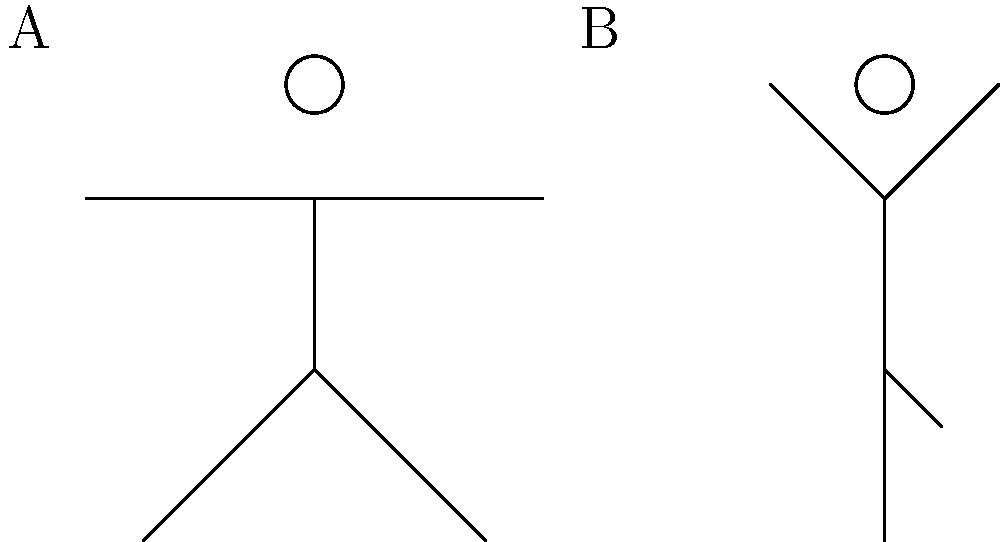As a nurse who understands the importance of stress relief, you recommend yoga to your patients. Which of the stick figure diagrams (A or B) represents the Warrior II pose, a stance known for building strength and reducing anxiety? To identify the Warrior II pose, let's analyze both stick figures:

1. Figure A:
   - Arms are extended horizontally
   - Legs are in a wide stance
   - One leg appears bent (front leg in Warrior II)
   - Upper body is upright

2. Figure B:
   - Arms are raised above the head
   - One leg is bent and placed against the other leg
   - Standing on one foot

Step-by-step analysis:
1. Warrior II pose characteristics:
   - Wide stance with legs apart
   - Front leg bent, back leg straight
   - Arms extended horizontally
   - Chest and hips face the side

2. Comparing to Figure A:
   - Wide stance: ✓
   - One leg appears bent: ✓
   - Arms extended horizontally: ✓
   - Upright posture: ✓

3. Comparing to Figure B:
   - Standing on one leg: ✗ (not a characteristic of Warrior II)
   - Arms raised above head: ✗ (not correct for Warrior II)

4. Conclusion:
   Figure A matches the characteristics of the Warrior II pose, while Figure B resembles the Tree pose.
Answer: A 